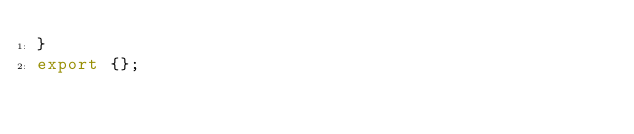Convert code to text. <code><loc_0><loc_0><loc_500><loc_500><_TypeScript_>}
export {};
</code> 